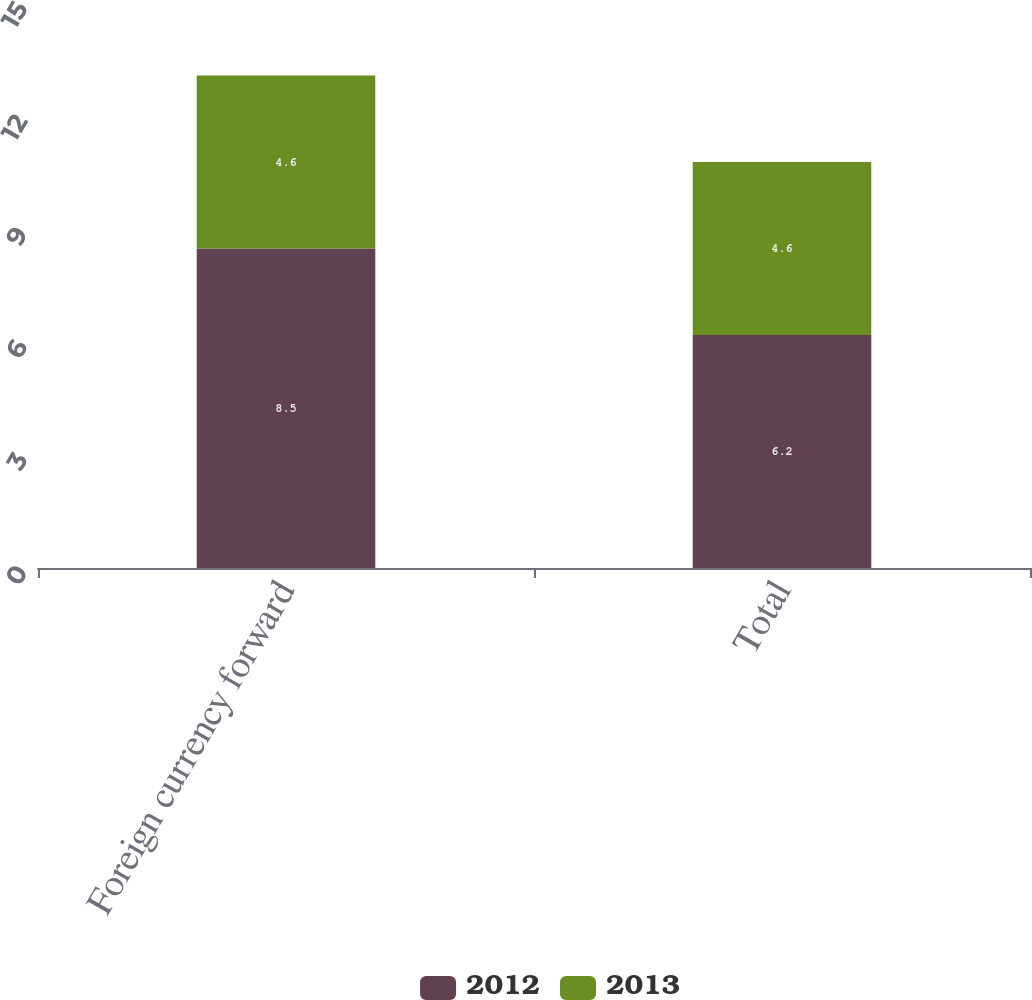<chart> <loc_0><loc_0><loc_500><loc_500><stacked_bar_chart><ecel><fcel>Foreign currency forward<fcel>Total<nl><fcel>2012<fcel>8.5<fcel>6.2<nl><fcel>2013<fcel>4.6<fcel>4.6<nl></chart> 